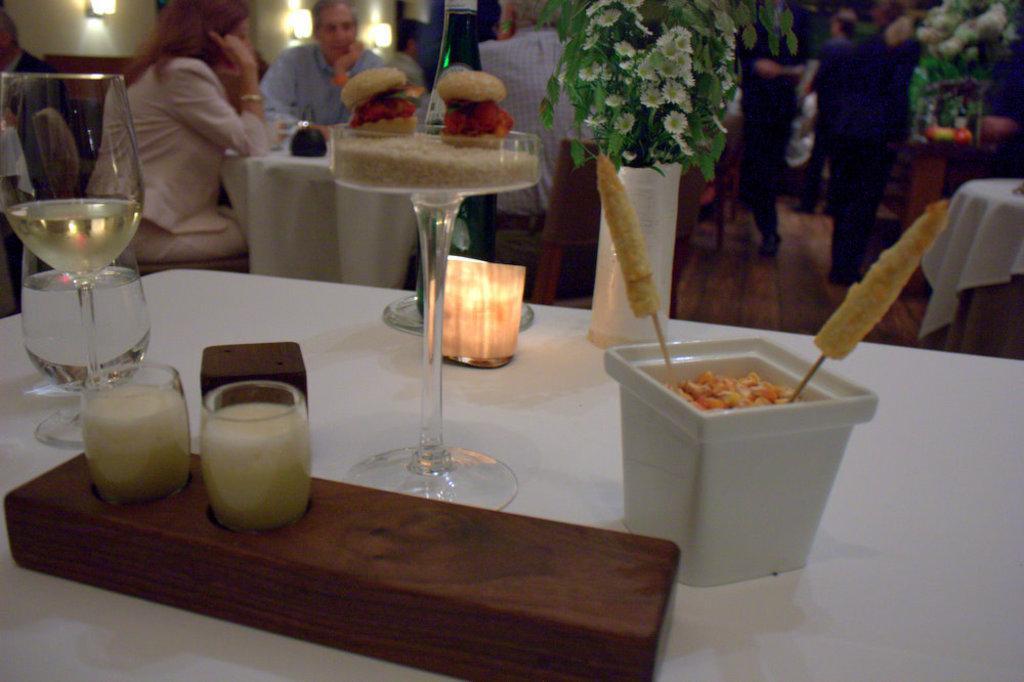Describe this image in one or two sentences. This is a table covered with white cloth. I can see a wine glass with wine,a flower vase with flowers,bowl a wooden object and some other object placed on it. At background I can see people sitting and standing. These are the wall lamps attached to the wall. 